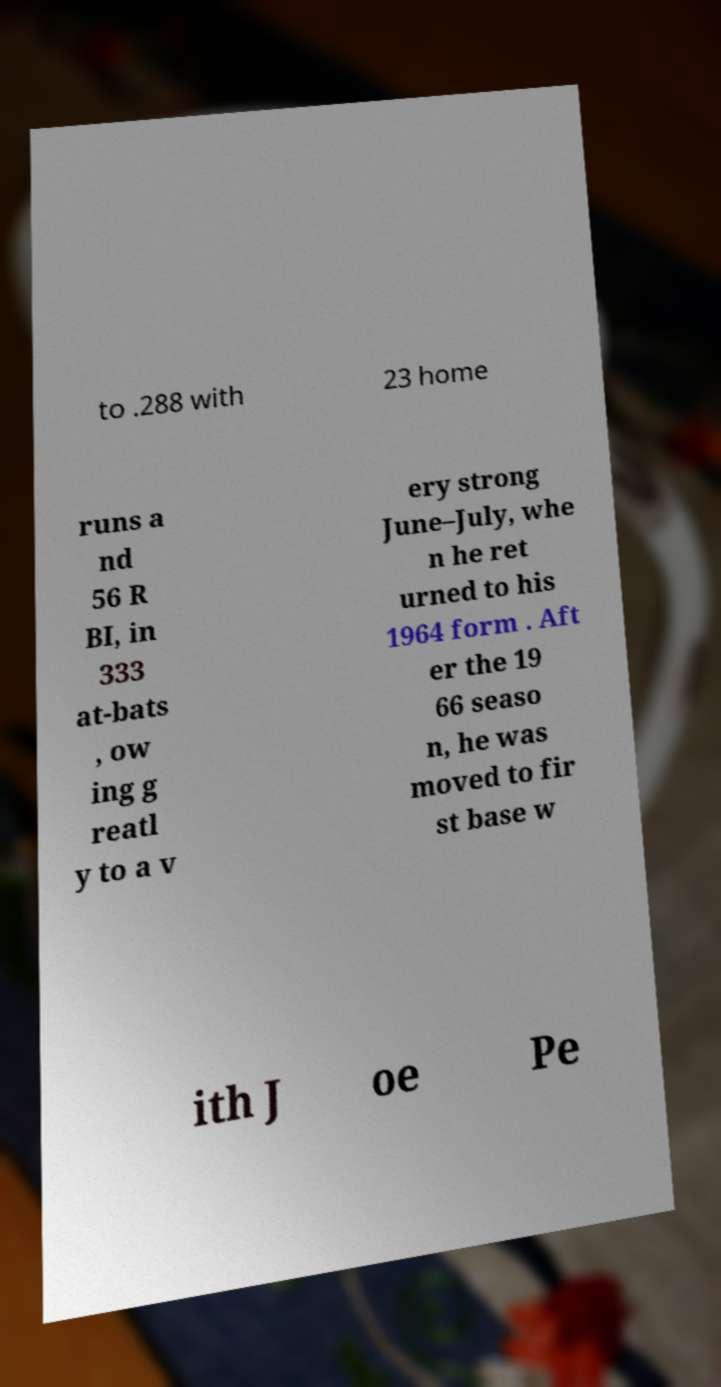Could you extract and type out the text from this image? to .288 with 23 home runs a nd 56 R BI, in 333 at-bats , ow ing g reatl y to a v ery strong June–July, whe n he ret urned to his 1964 form . Aft er the 19 66 seaso n, he was moved to fir st base w ith J oe Pe 